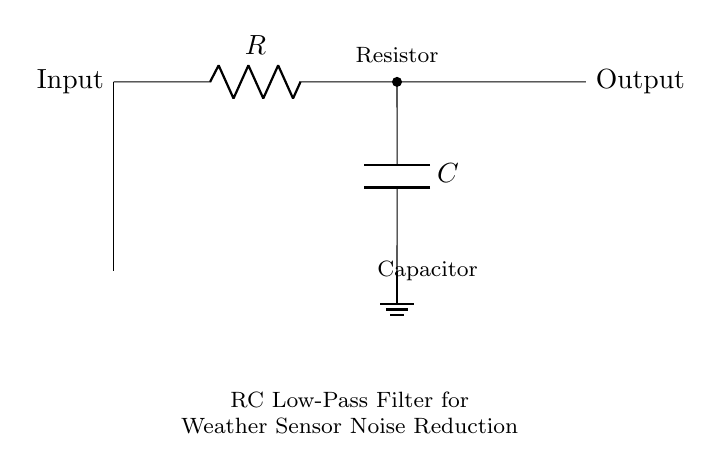What are the components in the circuit? The circuit contains a resistor and a capacitor, which are the primary components in an RC filter. The diagram explicitly labels both components: one as a resistor and the other as a capacitor.
Answer: Resistor and Capacitor What is the function of this circuit? The circuit functions as a low-pass filter, specifically designed to reduce noise in weather sensor readings. The description below the circuit explicitly states its purpose.
Answer: Low-pass filter What is the output of the circuit connected to? The output is connected to the right side of the circuit, which is shown as "Output." It suggests that the filtered signal is being sent to another component or device for further processing.
Answer: Output How many terminals does the capacitor have? The capacitor has two terminals: one connected to the resistor and one connected to the ground. This can be deduced from its representation in the diagram, where it shows both connections.
Answer: Two terminals What property does the capacitor provide in this RC circuit? The capacitor provides the property of charge storage, allowing it to filter out high-frequency noise while passing low-frequency signals through. This filtering effect is characteristic of capacitors in low-pass filter circuits.
Answer: Charge storage What is the expected output behavior of this filter for high-frequency noise? The expected behavior is that the output will show a reduced amplitude for high-frequency noise signals due to the filtering action of the capacitor. The RC combination is effective in attenuating higher frequencies while allowing lower frequencies to pass.
Answer: Reduced amplitude What is the purpose of the resistor in this circuit? The resistor limits the current flowing into the capacitor, which, in combination with the capacitor, determines the cutoff frequency of the filter. This relationship is critical for tuning the filter's response to the desired frequency range.
Answer: Limit current 